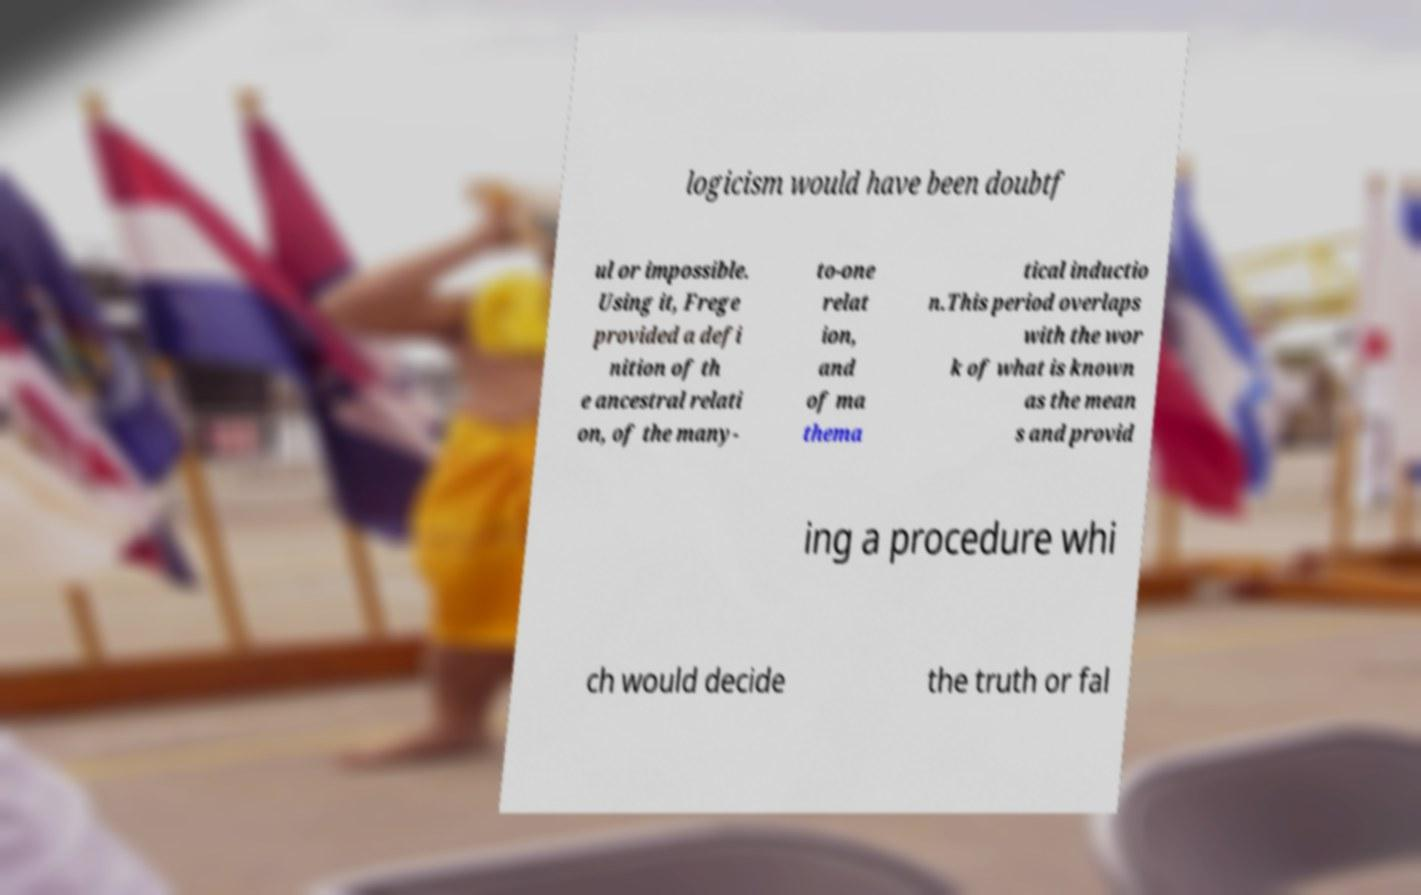Can you read and provide the text displayed in the image?This photo seems to have some interesting text. Can you extract and type it out for me? logicism would have been doubtf ul or impossible. Using it, Frege provided a defi nition of th e ancestral relati on, of the many- to-one relat ion, and of ma thema tical inductio n.This period overlaps with the wor k of what is known as the mean s and provid ing a procedure whi ch would decide the truth or fal 